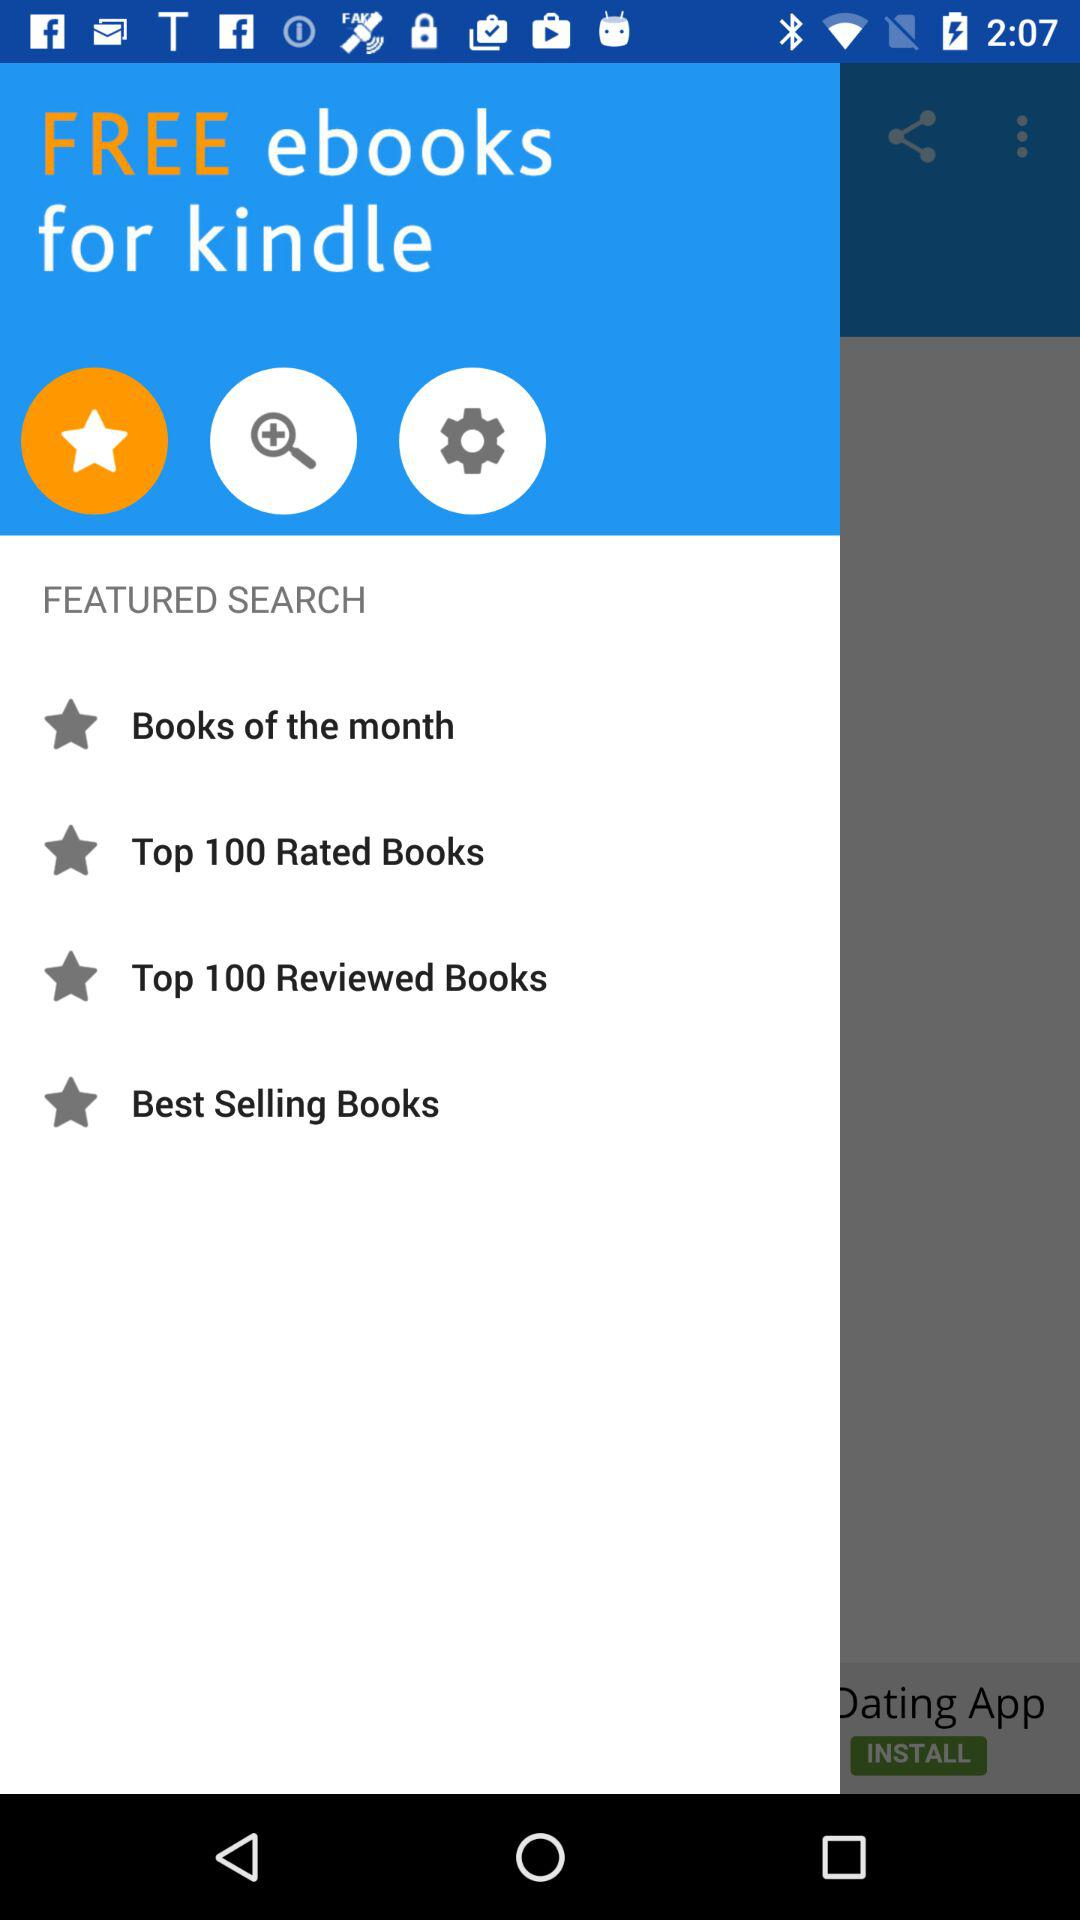What is the name of the application? The name of the application is "kindle". 